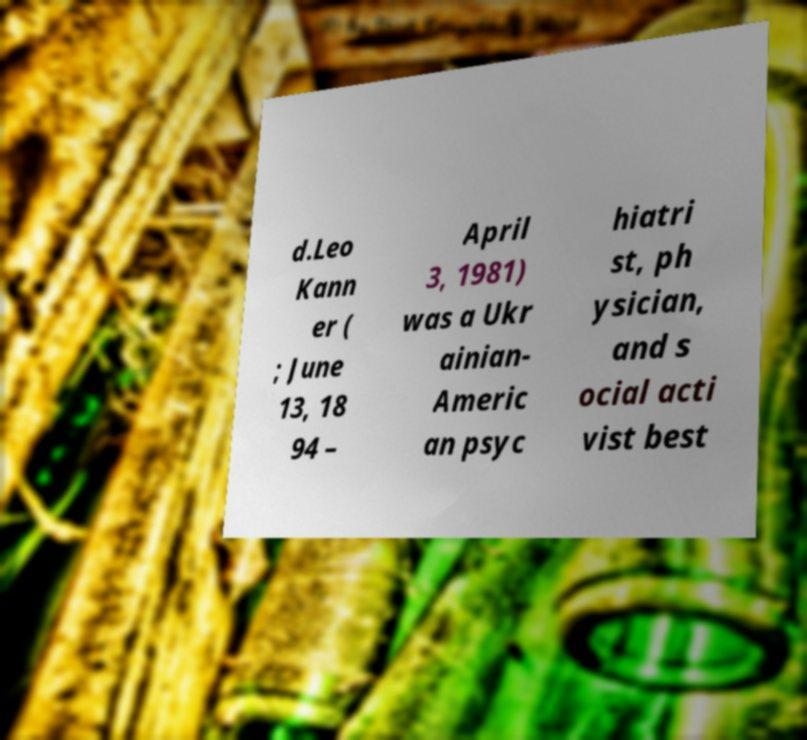What messages or text are displayed in this image? I need them in a readable, typed format. d.Leo Kann er ( ; June 13, 18 94 – April 3, 1981) was a Ukr ainian- Americ an psyc hiatri st, ph ysician, and s ocial acti vist best 